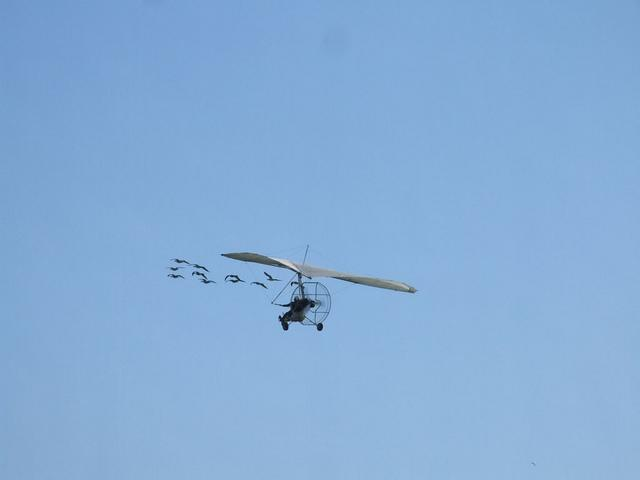Which object is/are in the greatest threat? birds 